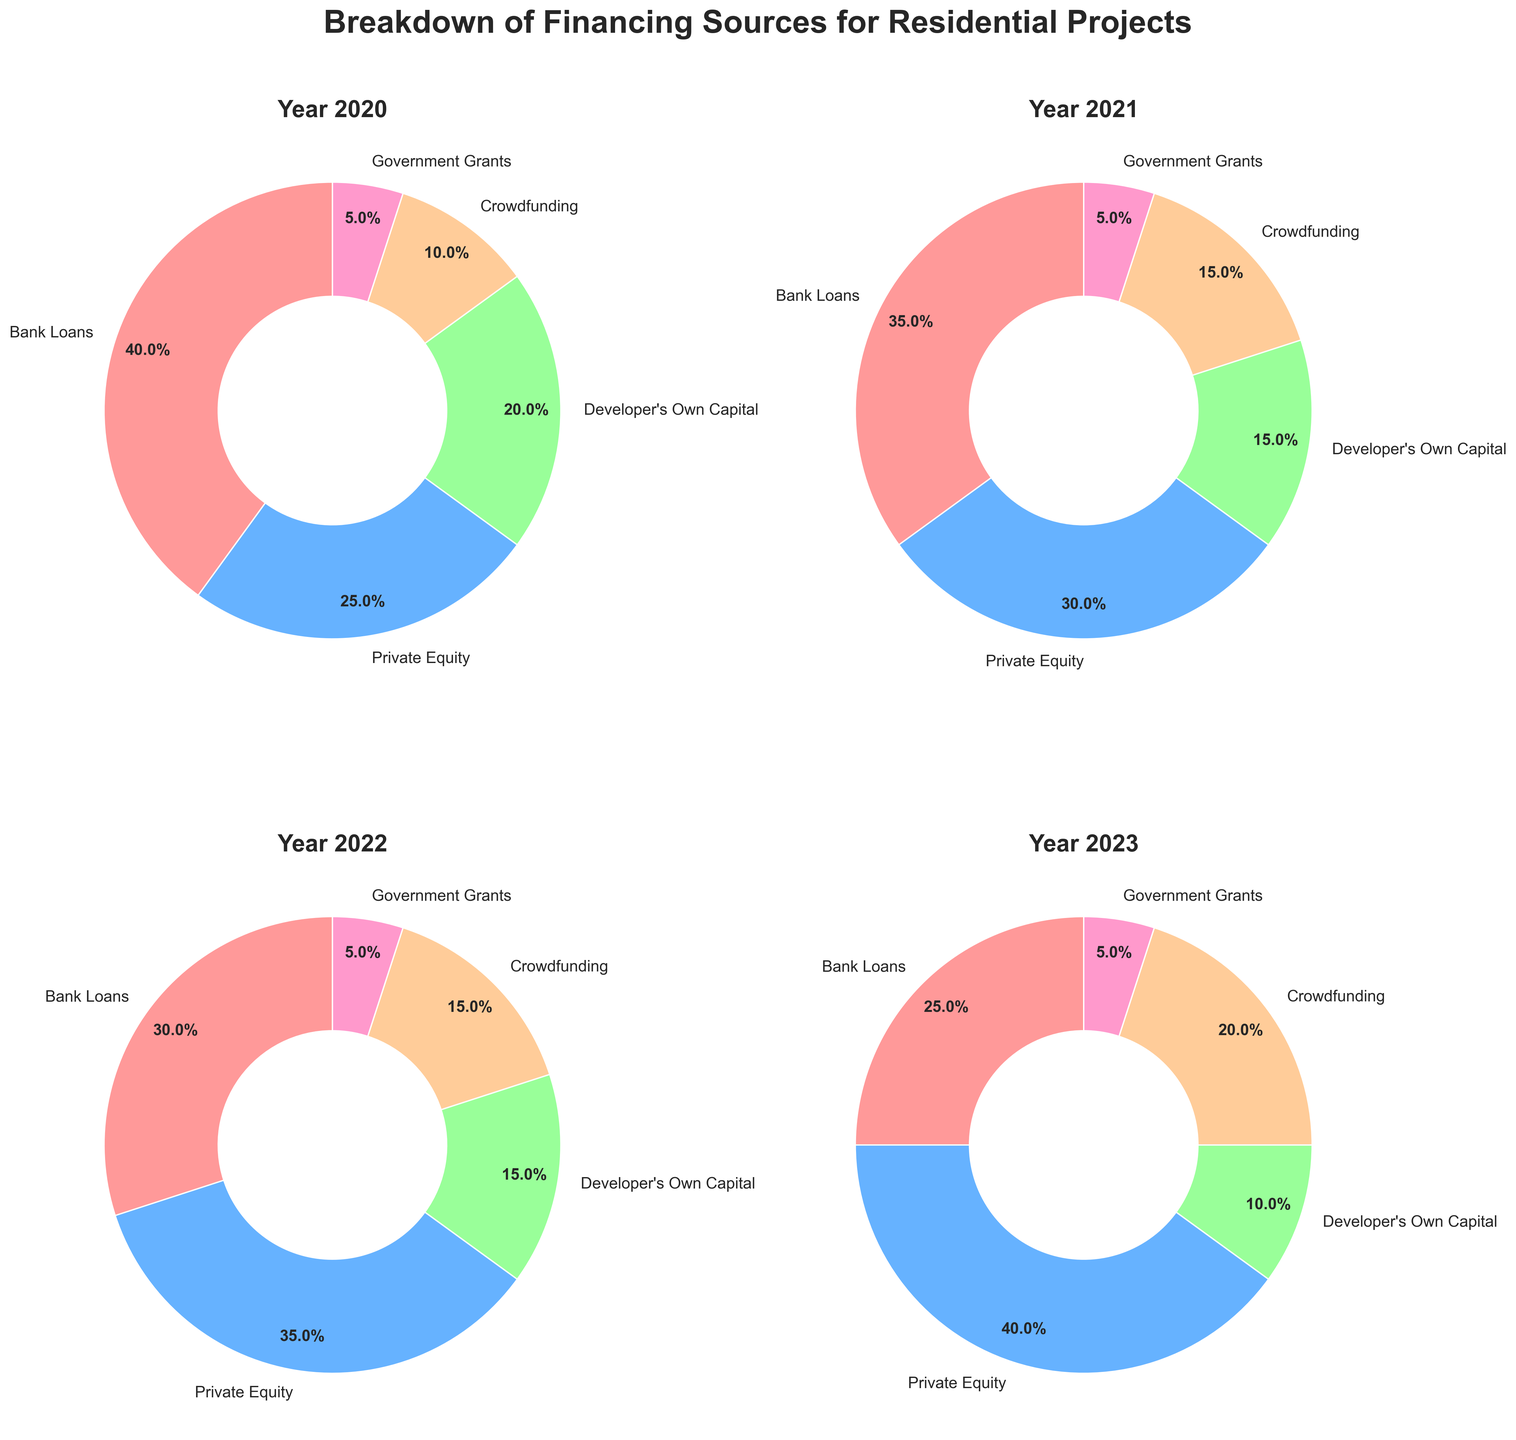Which year had the highest percentage of financing from Private Equity? According to the pie charts, Private Equity had the highest percentage in 2023 with 40%. To determine this, observe each pie chart in the figure, focusing on the section representing Private Equity and noting their respective percentages.
Answer: 2023 What is the average percentage of Crowdfunding across all four years? To find the average percentage of Crowdfunding, extract the values from each pie chart: 2020 (10%), 2021 (15%), 2022 (15%), 2023 (20%). Sum these percentages: 10 + 15 + 15 + 20 = 60, then divide by the number of years, which is 4. The calculation is 60 / 4.
Answer: 15% Which year had the lowest percentage of Bank Loans? By examining each year in the pie charts, it is clear that Bank Loans had the lowest percentage in 2023 at 25%.
Answer: 2023 In which year did Government Grants consistently remain the same percentage? Each pie chart shows Government Grants at a consistent 5% for all years: 2020, 2021, 2022, 2023.
Answer: All years Compare the Developer's Own Capital percentage between 2020 and 2023. How much did it decrease by? In 2020, the Developer's Own Capital was 20%, and it decreased to 10% in 2023. To find the decrease, subtract the 2023 value from the 2020 value: 20% - 10%.
Answer: 10% If you sum the percentages of Private Equity and Crowdfunding in 2023, what is the total? From the 2023 pie chart, Private Equity is at 40% and Crowdfunding is at 20%. Sum these percentages: 40 + 20.
Answer: 60% Which year showed the largest combined percentage for Bank Loans and Developer's Own Capital? To find the largest combined percentage, add Bank Loans and Developer's Own Capital for each year: 2020: 40%+20%=60%, 2021: 35%+15%=50%, 2022: 30%+15%=45%, 2023: 25%+10%=35%. The largest is in 2020 with 60%.
Answer: 2020 